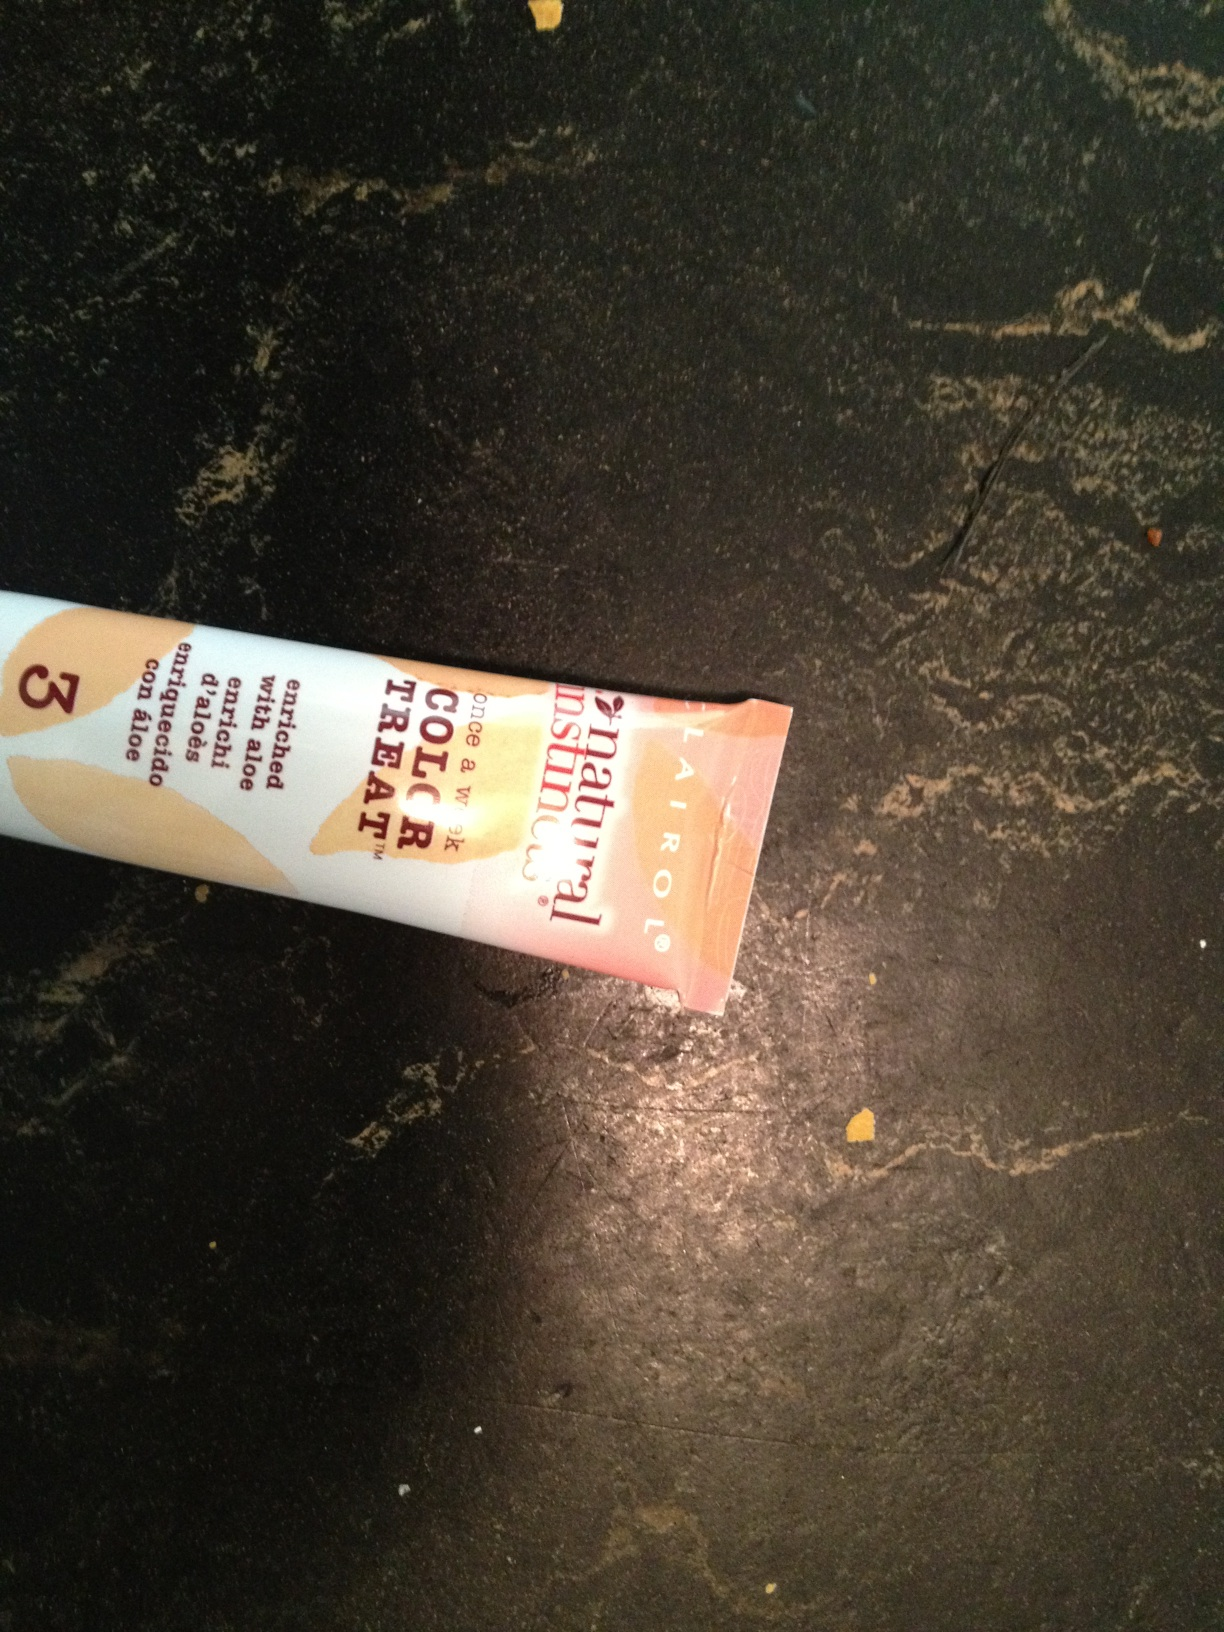what is this item? from Vizwiz This appears to be a tube of hair color treatment that includes natural ingredients such as aloe. The visible part of the label suggests it is an enriched formula, possibly intended to nourish the hair while providing color. Due to the angle and lack of full visibility, specific details like brand or color shade are not discernible. 